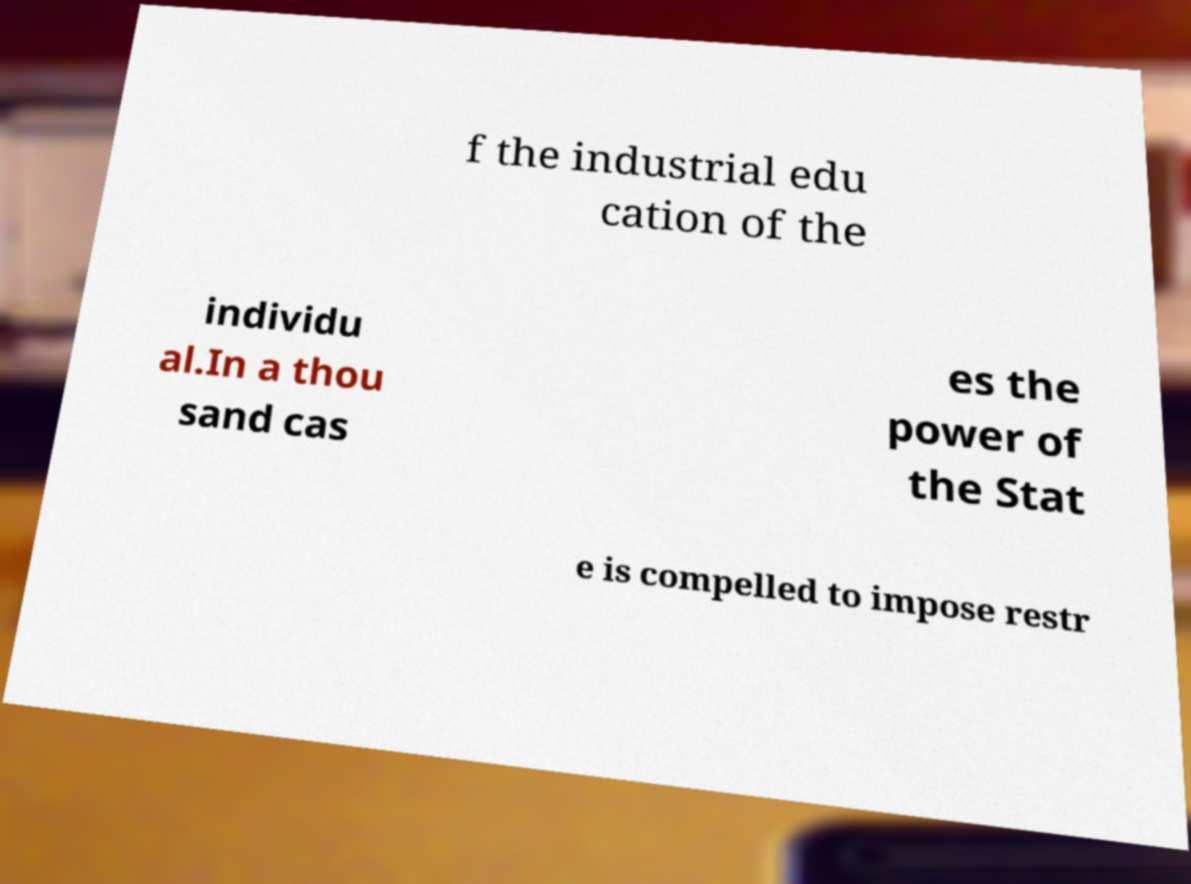What messages or text are displayed in this image? I need them in a readable, typed format. f the industrial edu cation of the individu al.In a thou sand cas es the power of the Stat e is compelled to impose restr 